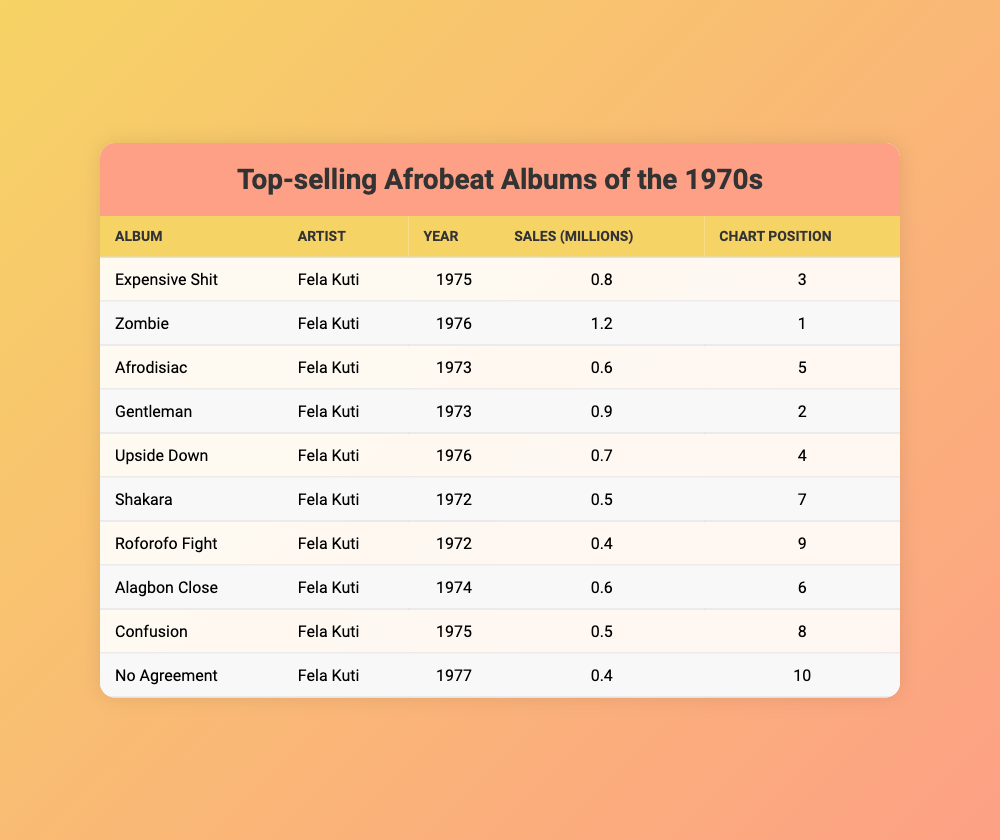What is the album with the highest sales in the table? The album with the highest sales is "Zombie" by Fela Kuti, which sold 1.2 million copies.
Answer: Zombie Which year had the highest-selling album? The year 1976 had the highest-selling album, "Zombie" by Fela Kuti, with sales of 1.2 million.
Answer: 1976 What is the total sales of all albums listed in the table? Adding the sales figures gives us 0.8 + 1.2 + 0.6 + 0.9 + 0.7 + 0.5 + 0.4 + 0.6 + 0.5 + 0.4 = 5.6 million, thus the total sales is 5.6 million.
Answer: 5.6 million Is there any album by Fela Kuti that sold more than 1 million copies? Yes, "Zombie" sold 1.2 million copies, which is more than 1 million.
Answer: Yes What chart position did the album "Afrodisiac" achieve? The album "Afrodisiac" achieved a chart position of 5.
Answer: 5 What is the average sales of the albums listed in the table? The total number of albums is 10, and the total sales is 5.6 million. Dividing gives an average of 5.6 million / 10 = 0.56 million.
Answer: 0.56 million Which albums were released in the year 1973? The albums released in 1973 are "Afrodisiac" and "Gentleman".
Answer: Afrodisiac and Gentleman Which album had the lowest chart position? The album with the lowest chart position is "No Agreement," which is at position 10.
Answer: No Agreement How many albums sold less than 0.6 million copies? The albums that sold less than 0.6 million are "Shakara" (0.5 million), "Roforofo Fight" (0.4 million), and "No Agreement" (0.4 million), totaling 3 albums.
Answer: 3 What is the difference in sales between "Zombie" and "Expensive Shit"? "Zombie" sold 1.2 million while "Expensive Shit" sold 0.8 million; the difference is 1.2 million - 0.8 million = 0.4 million.
Answer: 0.4 million 